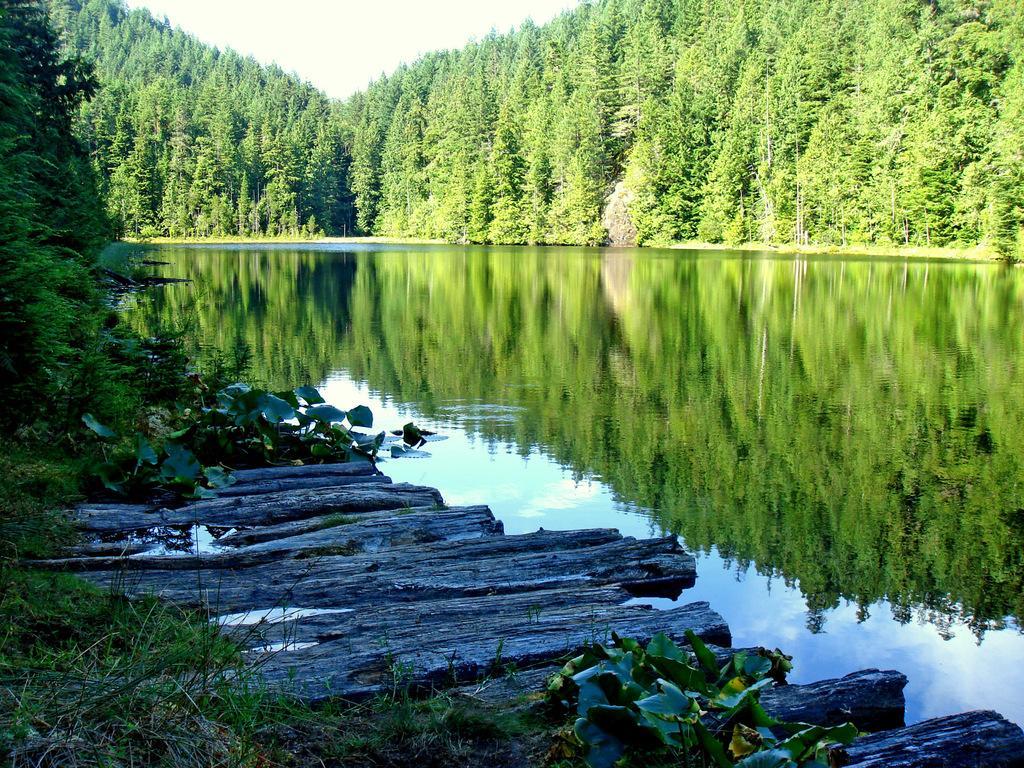Could you give a brief overview of what you see in this image? In this picture I can see there is a lake, trees, and plants and the sky is clear. 